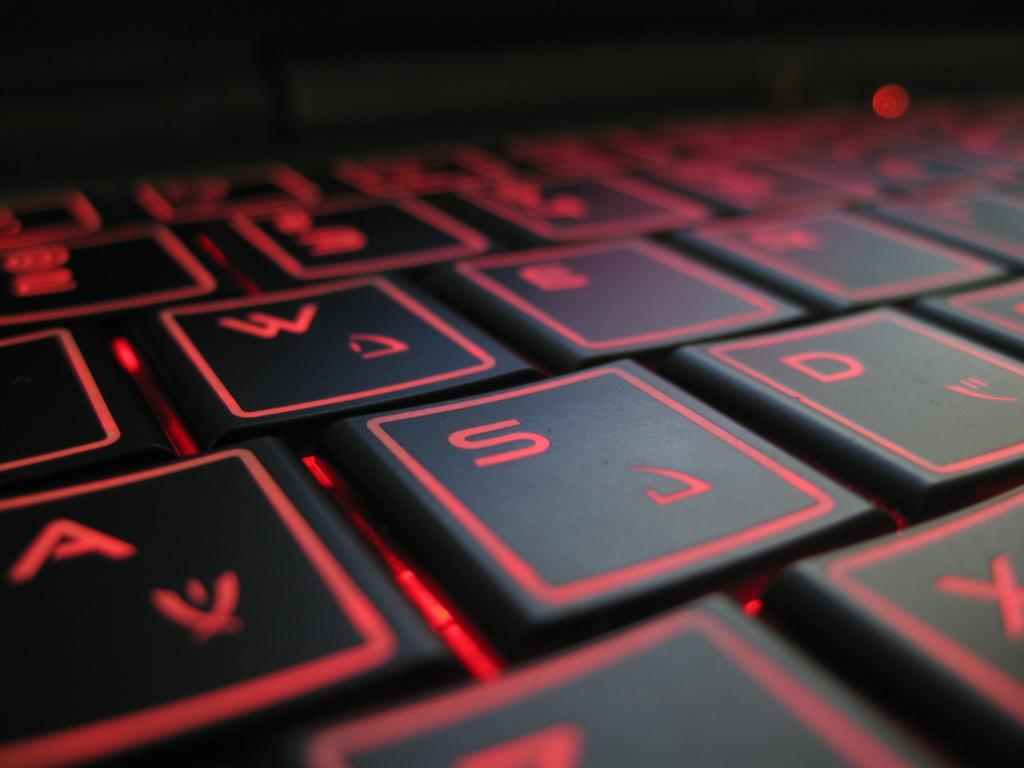<image>
Summarize the visual content of the image. Black and red square keys showing the S key between the A and D key. 